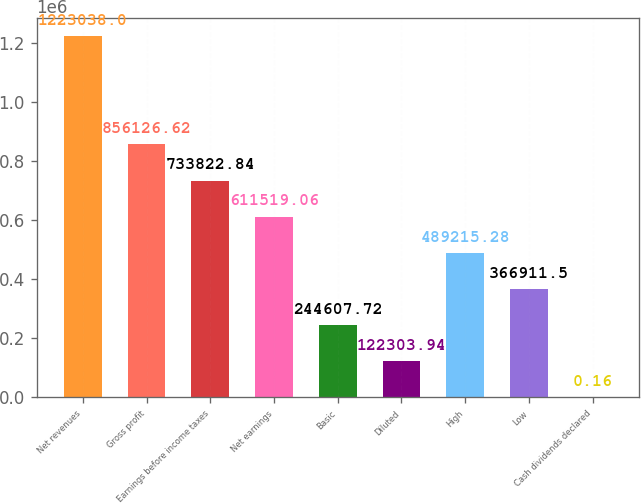Convert chart to OTSL. <chart><loc_0><loc_0><loc_500><loc_500><bar_chart><fcel>Net revenues<fcel>Gross profit<fcel>Earnings before income taxes<fcel>Net earnings<fcel>Basic<fcel>Diluted<fcel>High<fcel>Low<fcel>Cash dividends declared<nl><fcel>1.22304e+06<fcel>856127<fcel>733823<fcel>611519<fcel>244608<fcel>122304<fcel>489215<fcel>366912<fcel>0.16<nl></chart> 